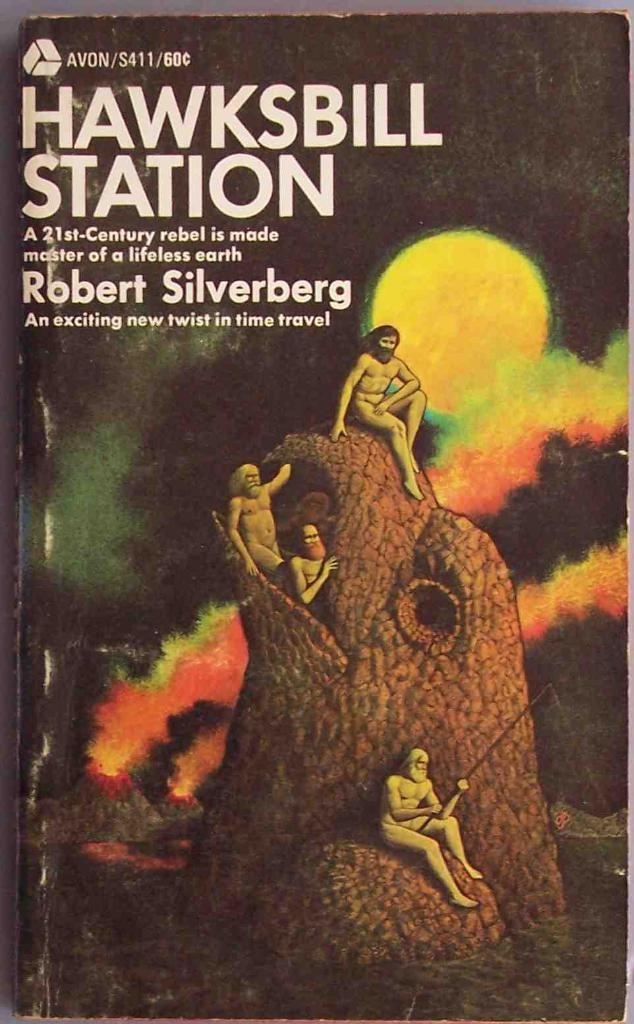<image>
Create a compact narrative representing the image presented. A time travel book by Robert Silverberg titled Hawksbill Station. 